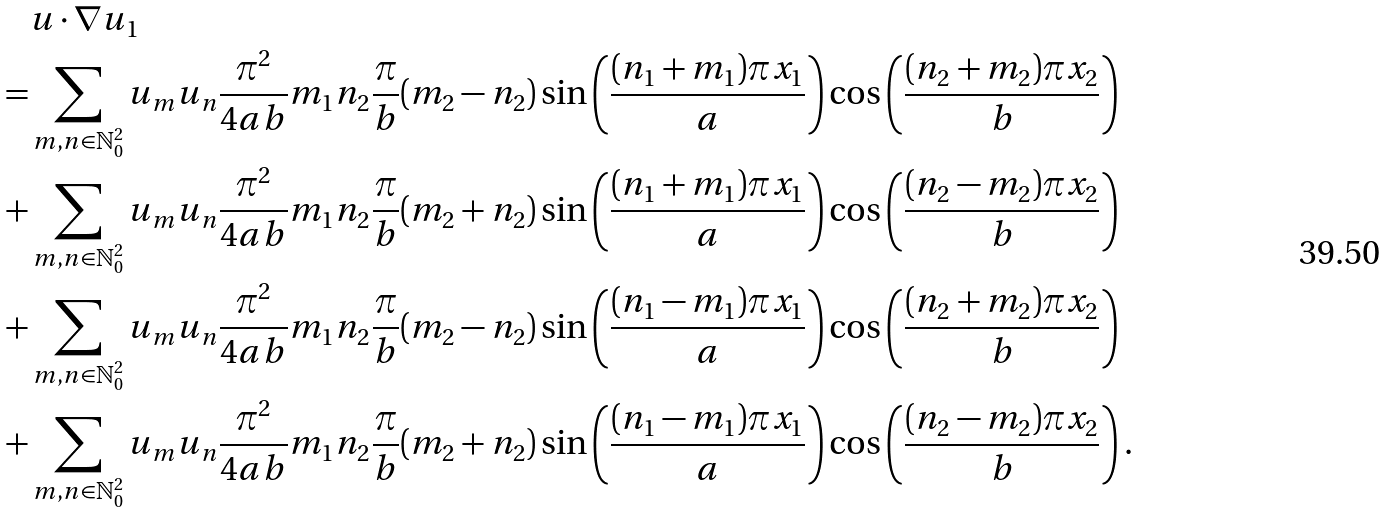Convert formula to latex. <formula><loc_0><loc_0><loc_500><loc_500>& u \cdot \nabla u _ { 1 } \\ = & \sum _ { m , n \in \mathbb { N } _ { 0 } ^ { 2 } } u _ { m } u _ { n } \frac { \pi ^ { 2 } } { 4 a b } m _ { 1 } n _ { 2 } \frac { \pi } { b } ( m _ { 2 } - n _ { 2 } ) \sin \left ( \frac { ( n _ { 1 } + m _ { 1 } ) \pi x _ { 1 } } { a } \right ) \cos \left ( \frac { ( n _ { 2 } + m _ { 2 } ) \pi x _ { 2 } } { b } \right ) \\ + & \sum _ { m , n \in \mathbb { N } _ { 0 } ^ { 2 } } u _ { m } u _ { n } \frac { \pi ^ { 2 } } { 4 a b } m _ { 1 } n _ { 2 } \frac { \pi } { b } ( m _ { 2 } + n _ { 2 } ) \sin \left ( \frac { ( n _ { 1 } + m _ { 1 } ) \pi x _ { 1 } } { a } \right ) \cos \left ( \frac { ( n _ { 2 } - m _ { 2 } ) \pi x _ { 2 } } { b } \right ) \\ + & \sum _ { m , n \in \mathbb { N } _ { 0 } ^ { 2 } } u _ { m } u _ { n } \frac { \pi ^ { 2 } } { 4 a b } m _ { 1 } n _ { 2 } \frac { \pi } { b } ( m _ { 2 } - n _ { 2 } ) \sin \left ( \frac { ( n _ { 1 } - m _ { 1 } ) \pi x _ { 1 } } { a } \right ) \cos \left ( \frac { ( n _ { 2 } + m _ { 2 } ) \pi x _ { 2 } } { b } \right ) \\ + & \sum _ { m , n \in \mathbb { N } _ { 0 } ^ { 2 } } u _ { m } u _ { n } \frac { \pi ^ { 2 } } { 4 a b } m _ { 1 } n _ { 2 } \frac { \pi } { b } ( m _ { 2 } + n _ { 2 } ) \sin \left ( \frac { ( n _ { 1 } - m _ { 1 } ) \pi x _ { 1 } } { a } \right ) \cos \left ( \frac { ( n _ { 2 } - m _ { 2 } ) \pi x _ { 2 } } { b } \right ) .</formula> 